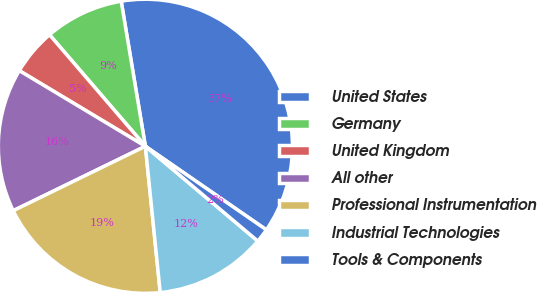Convert chart to OTSL. <chart><loc_0><loc_0><loc_500><loc_500><pie_chart><fcel>United States<fcel>Germany<fcel>United Kingdom<fcel>All other<fcel>Professional Instrumentation<fcel>Industrial Technologies<fcel>Tools & Components<nl><fcel>37.25%<fcel>8.67%<fcel>5.1%<fcel>15.82%<fcel>19.39%<fcel>12.24%<fcel>1.53%<nl></chart> 